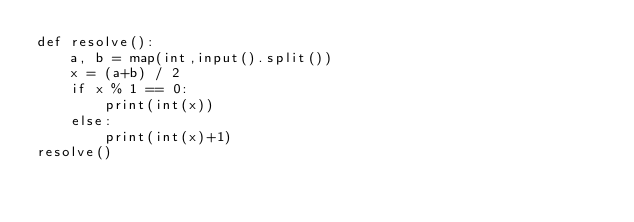<code> <loc_0><loc_0><loc_500><loc_500><_Python_>def resolve():
    a, b = map(int,input().split())
    x = (a+b) / 2
    if x % 1 == 0:
        print(int(x))
    else:
        print(int(x)+1)
resolve()
</code> 